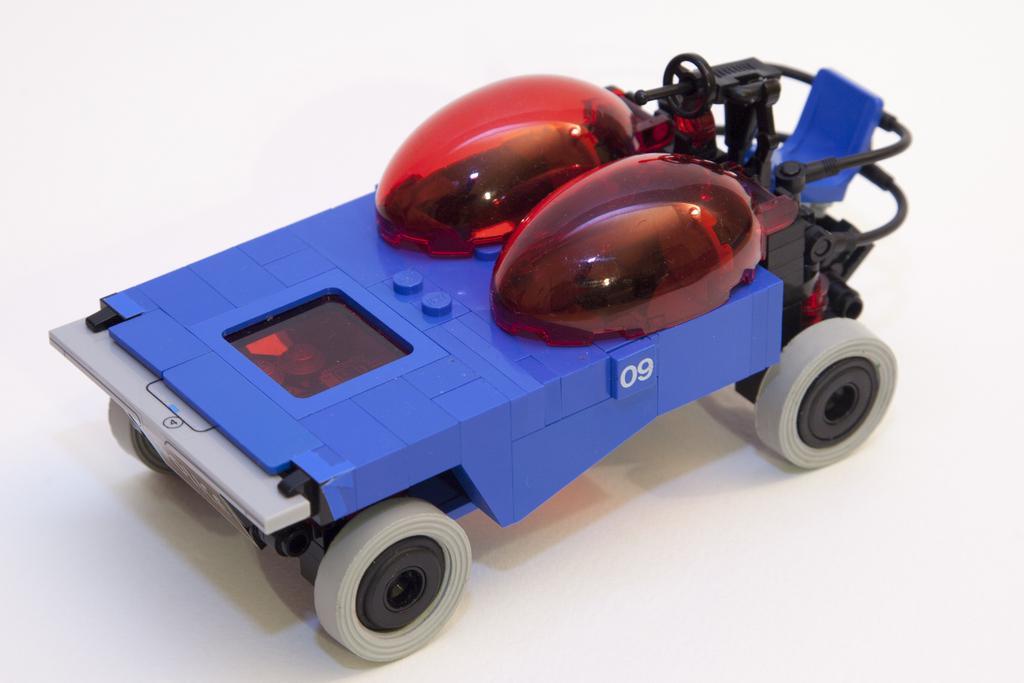Describe this image in one or two sentences. In this image we can see a toy car placed on the surface. 